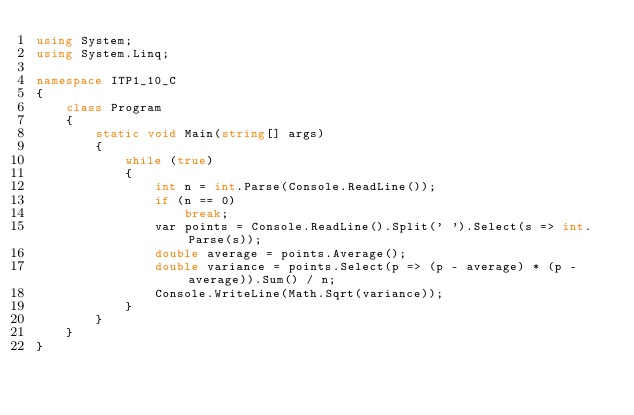<code> <loc_0><loc_0><loc_500><loc_500><_C#_>using System;
using System.Linq;

namespace ITP1_10_C
{
    class Program
    {
        static void Main(string[] args)
        {
            while (true)
            {
                int n = int.Parse(Console.ReadLine());
                if (n == 0)
                    break;
                var points = Console.ReadLine().Split(' ').Select(s => int.Parse(s));
                double average = points.Average();
                double variance = points.Select(p => (p - average) * (p - average)).Sum() / n;
                Console.WriteLine(Math.Sqrt(variance));
            }
        }
    }
}</code> 